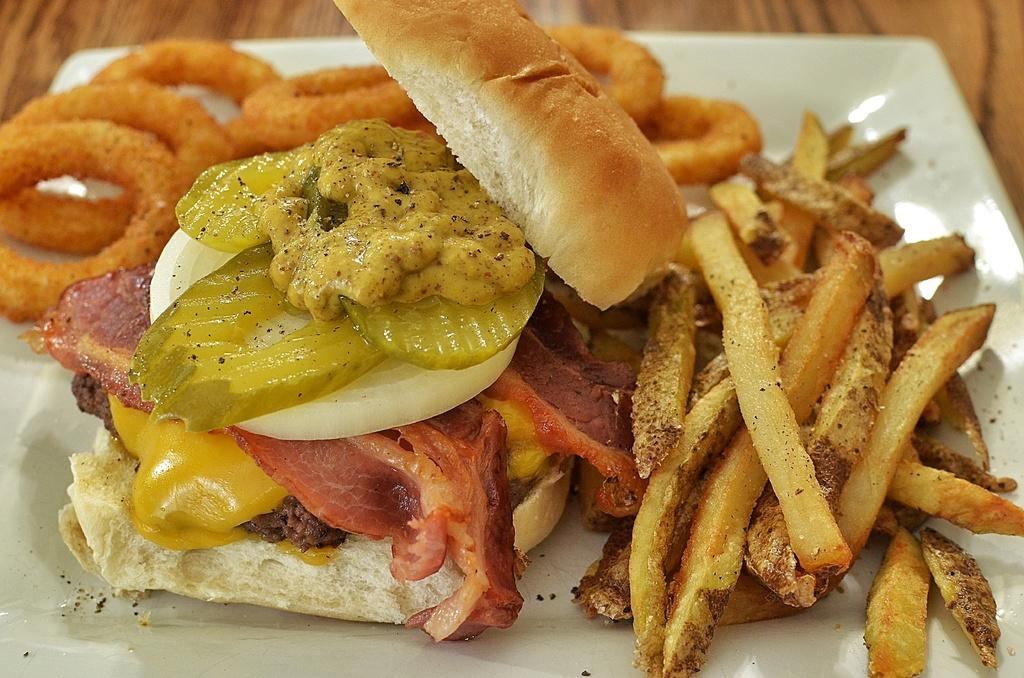What is located in the center of the image? There is a tray in the center of the image. What food items are on the tray? The tray contains french fries and a burger. What type of sign can be seen in the image? There is no sign present in the image. How many legs are visible in the image? There are no legs visible in the image. 